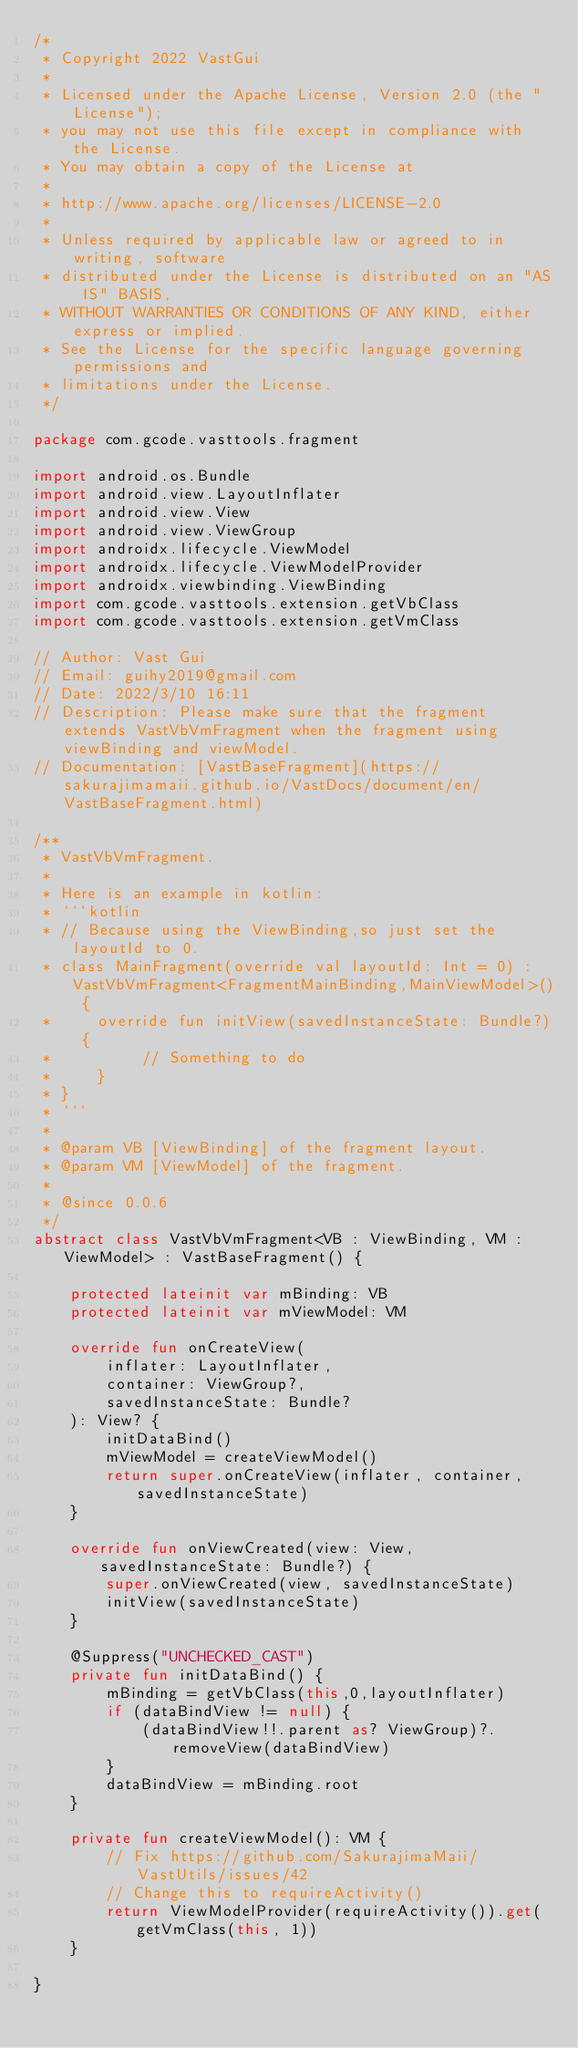<code> <loc_0><loc_0><loc_500><loc_500><_Kotlin_>/*
 * Copyright 2022 VastGui
 *
 * Licensed under the Apache License, Version 2.0 (the "License");
 * you may not use this file except in compliance with the License.
 * You may obtain a copy of the License at
 *
 * http://www.apache.org/licenses/LICENSE-2.0
 *
 * Unless required by applicable law or agreed to in writing, software
 * distributed under the License is distributed on an "AS IS" BASIS,
 * WITHOUT WARRANTIES OR CONDITIONS OF ANY KIND, either express or implied.
 * See the License for the specific language governing permissions and
 * limitations under the License.
 */

package com.gcode.vasttools.fragment

import android.os.Bundle
import android.view.LayoutInflater
import android.view.View
import android.view.ViewGroup
import androidx.lifecycle.ViewModel
import androidx.lifecycle.ViewModelProvider
import androidx.viewbinding.ViewBinding
import com.gcode.vasttools.extension.getVbClass
import com.gcode.vasttools.extension.getVmClass

// Author: Vast Gui
// Email: guihy2019@gmail.com
// Date: 2022/3/10 16:11
// Description: Please make sure that the fragment extends VastVbVmFragment when the fragment using viewBinding and viewModel.
// Documentation: [VastBaseFragment](https://sakurajimamaii.github.io/VastDocs/document/en/VastBaseFragment.html)

/**
 * VastVbVmFragment.
 *
 * Here is an example in kotlin:
 * ```kotlin
 * // Because using the ViewBinding,so just set the layoutId to 0.
 * class MainFragment(override val layoutId: Int = 0) : VastVbVmFragment<FragmentMainBinding,MainViewModel>() {
 *     override fun initView(savedInstanceState: Bundle?) {
 *          // Something to do
 *     }
 * }
 * ```
 *
 * @param VB [ViewBinding] of the fragment layout.
 * @param VM [ViewModel] of the fragment.
 *
 * @since 0.0.6
 */
abstract class VastVbVmFragment<VB : ViewBinding, VM : ViewModel> : VastBaseFragment() {

    protected lateinit var mBinding: VB
    protected lateinit var mViewModel: VM

    override fun onCreateView(
        inflater: LayoutInflater,
        container: ViewGroup?,
        savedInstanceState: Bundle?
    ): View? {
        initDataBind()
        mViewModel = createViewModel()
        return super.onCreateView(inflater, container, savedInstanceState)
    }

    override fun onViewCreated(view: View, savedInstanceState: Bundle?) {
        super.onViewCreated(view, savedInstanceState)
        initView(savedInstanceState)
    }

    @Suppress("UNCHECKED_CAST")
    private fun initDataBind() {
        mBinding = getVbClass(this,0,layoutInflater)
        if (dataBindView != null) {
            (dataBindView!!.parent as? ViewGroup)?.removeView(dataBindView)
        }
        dataBindView = mBinding.root
    }

    private fun createViewModel(): VM {
        // Fix https://github.com/SakurajimaMaii/VastUtils/issues/42
        // Change this to requireActivity()
        return ViewModelProvider(requireActivity()).get(getVmClass(this, 1))
    }

}</code> 